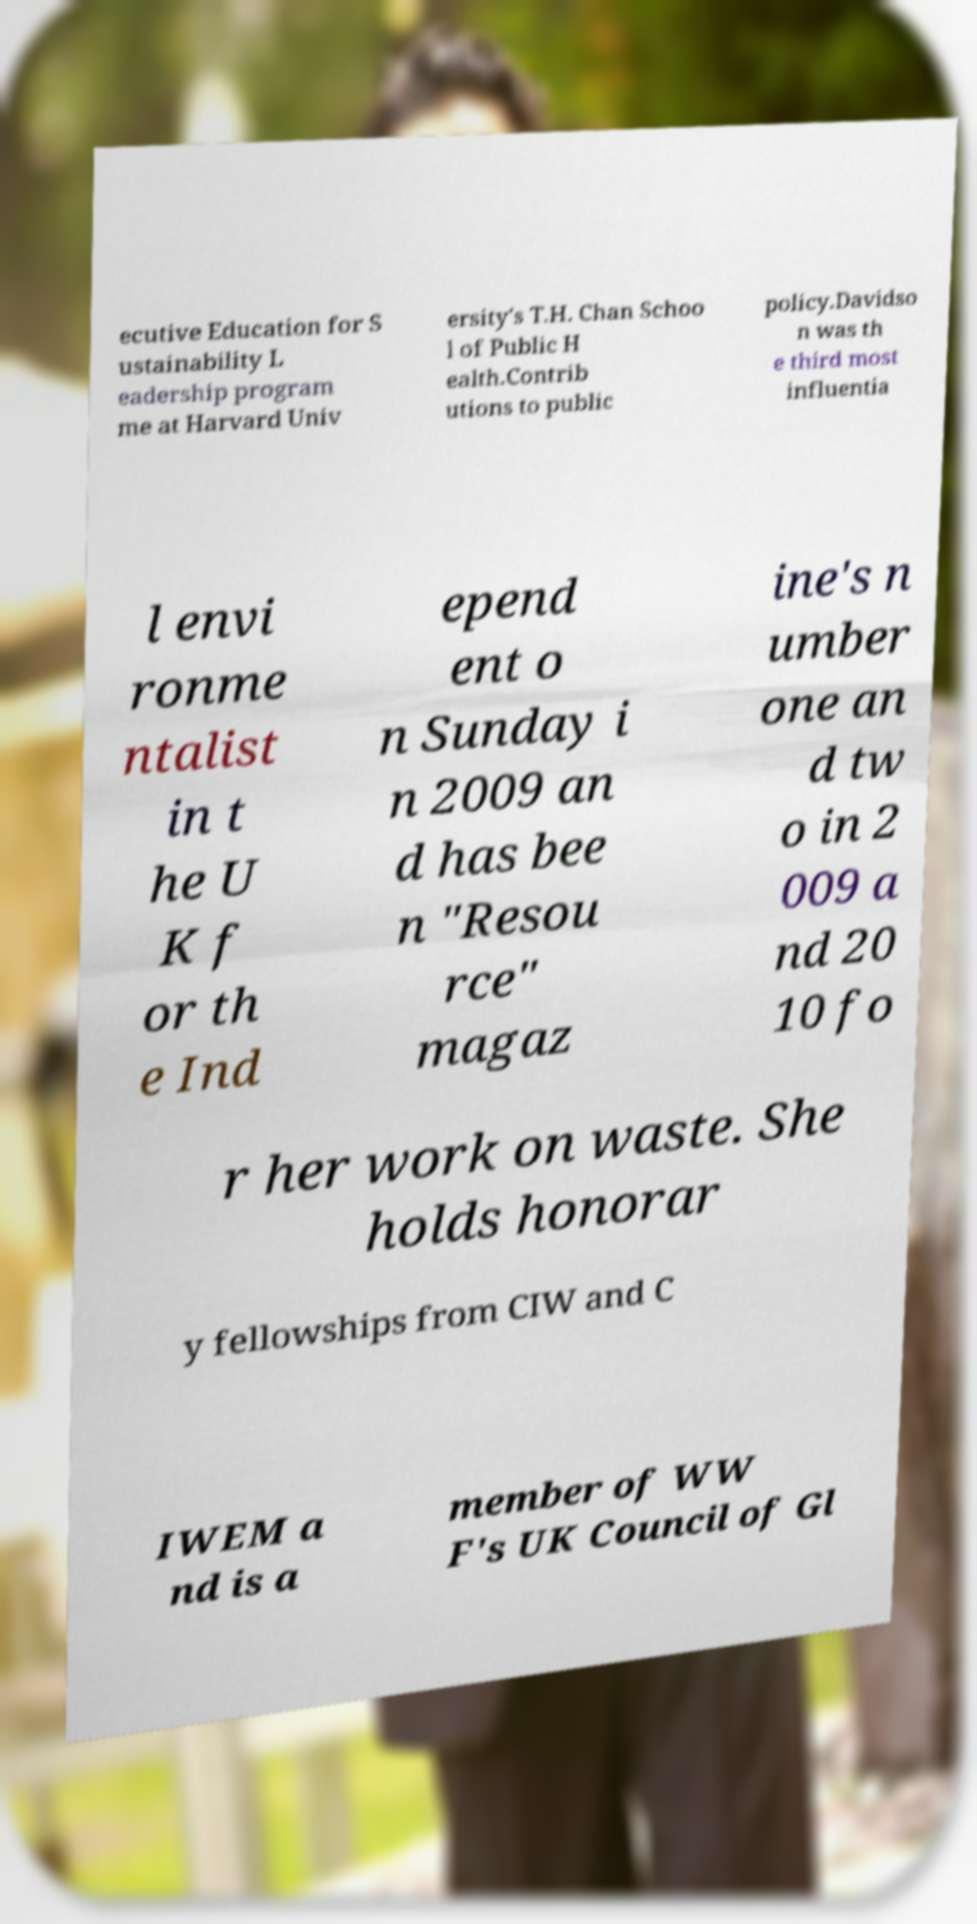Could you assist in decoding the text presented in this image and type it out clearly? ecutive Education for S ustainability L eadership program me at Harvard Univ ersity's T.H. Chan Schoo l of Public H ealth.Contrib utions to public policy.Davidso n was th e third most influentia l envi ronme ntalist in t he U K f or th e Ind epend ent o n Sunday i n 2009 an d has bee n "Resou rce" magaz ine's n umber one an d tw o in 2 009 a nd 20 10 fo r her work on waste. She holds honorar y fellowships from CIW and C IWEM a nd is a member of WW F's UK Council of Gl 